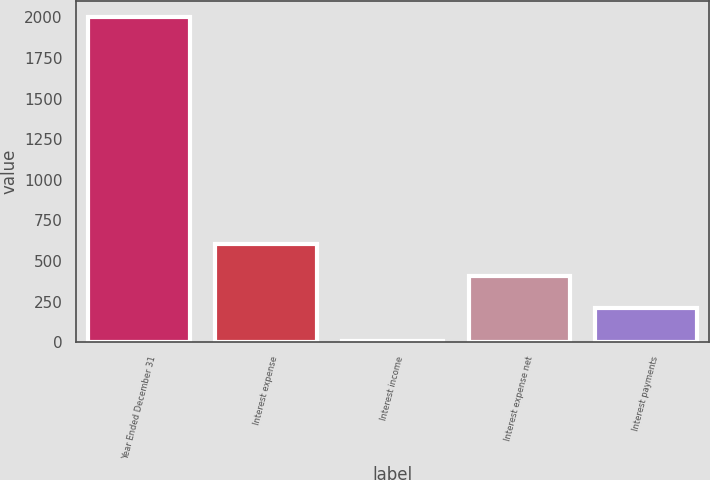Convert chart. <chart><loc_0><loc_0><loc_500><loc_500><bar_chart><fcel>Year Ended December 31<fcel>Interest expense<fcel>Interest income<fcel>Interest expense net<fcel>Interest payments<nl><fcel>2003<fcel>607.9<fcel>10<fcel>408.6<fcel>209.3<nl></chart> 